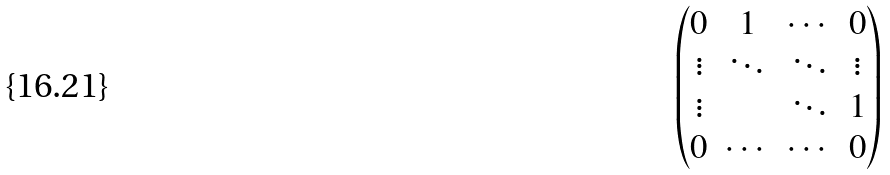Convert formula to latex. <formula><loc_0><loc_0><loc_500><loc_500>\begin{pmatrix} 0 & 1 & \cdots & 0 \\ \vdots & \ddots & \ddots & \vdots \\ \vdots & & \ddots & 1 \\ 0 & \cdots & \cdots & 0 \end{pmatrix}</formula> 